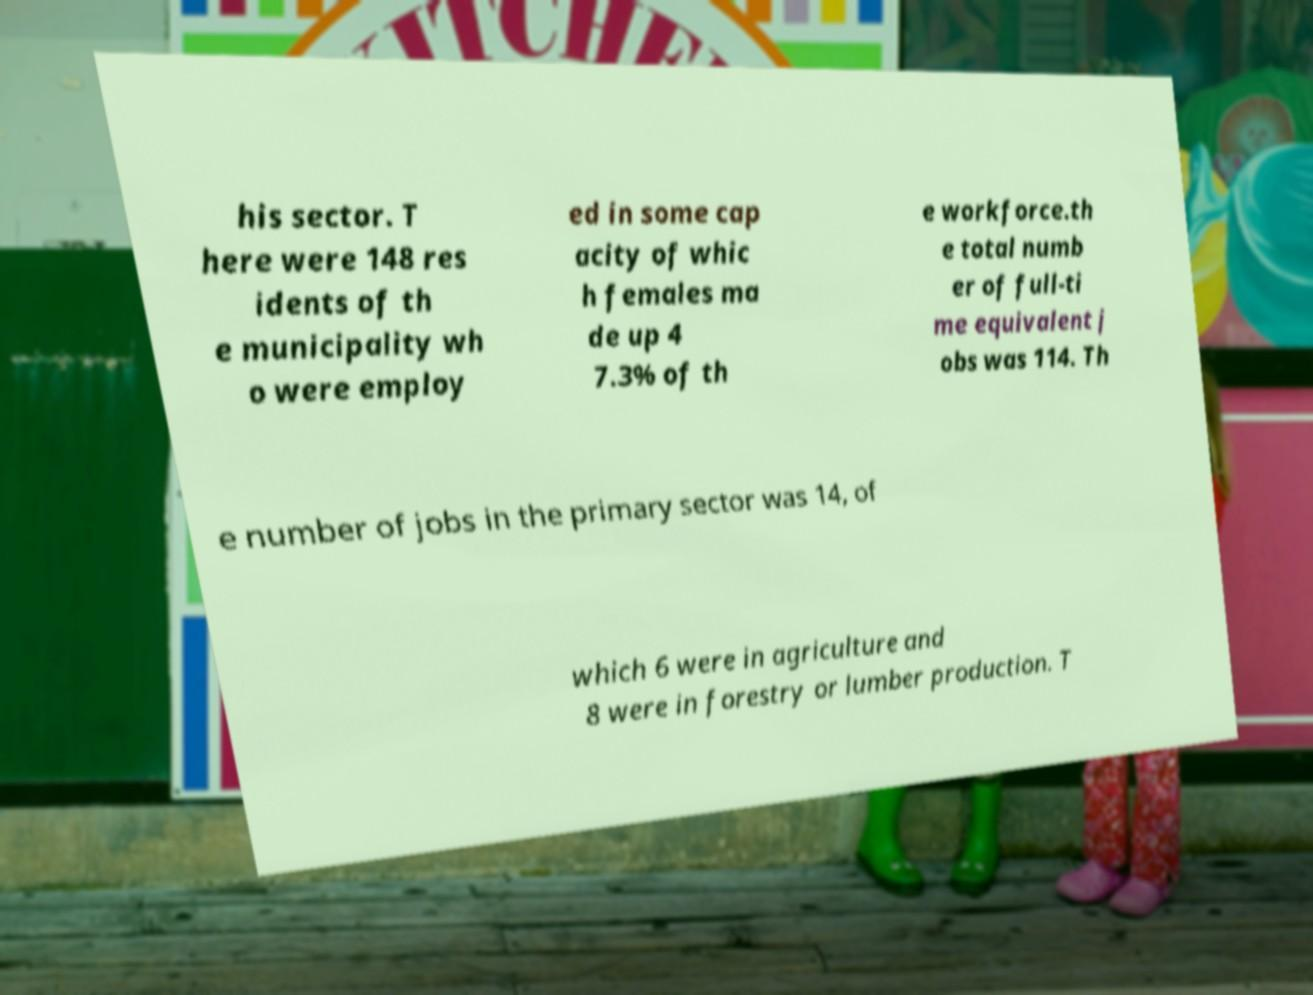Can you accurately transcribe the text from the provided image for me? his sector. T here were 148 res idents of th e municipality wh o were employ ed in some cap acity of whic h females ma de up 4 7.3% of th e workforce.th e total numb er of full-ti me equivalent j obs was 114. Th e number of jobs in the primary sector was 14, of which 6 were in agriculture and 8 were in forestry or lumber production. T 